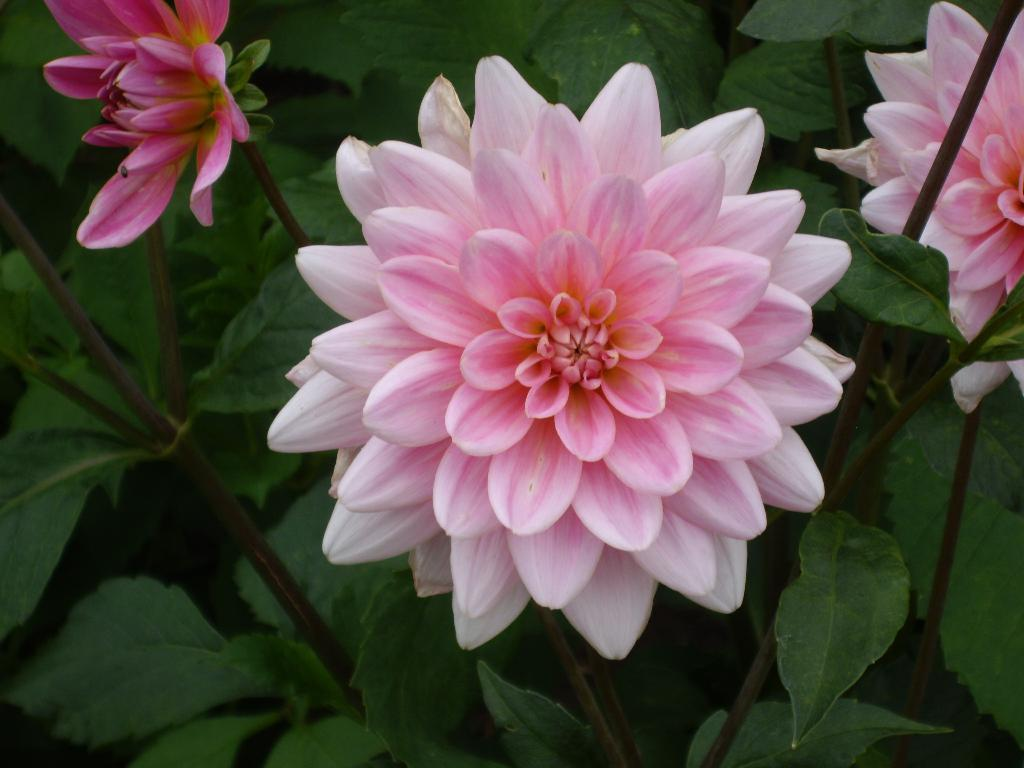What type of living organisms can be seen in the image? Flowers and plants are visible in the image. Can you describe the plants in the image? The image contains flowers, which are a type of plant. What type of collar can be seen on the flowers in the image? There is no collar present on the flowers in the image. 